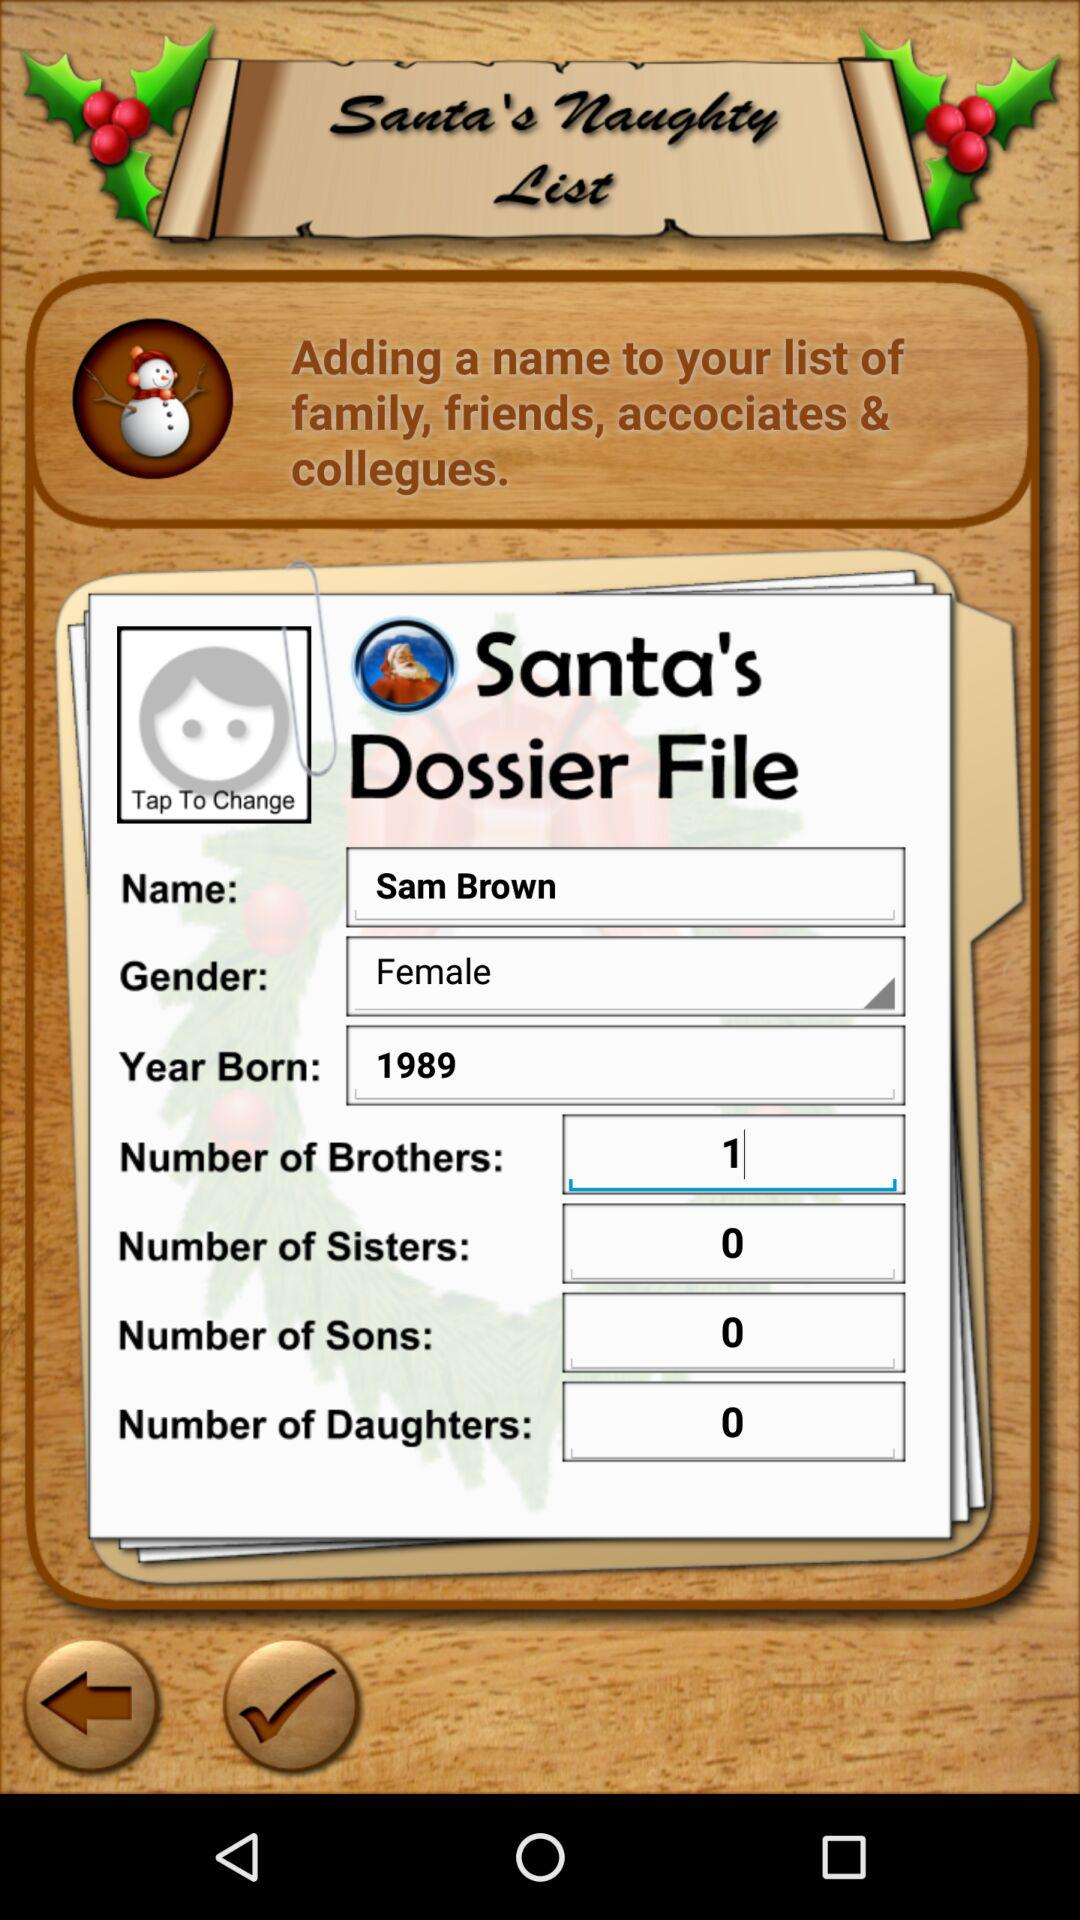What is the application name? The application name is "Santa's Naughty List". 